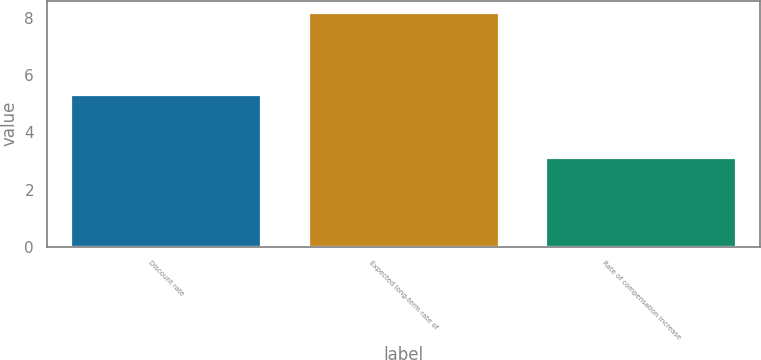Convert chart. <chart><loc_0><loc_0><loc_500><loc_500><bar_chart><fcel>Discount rate<fcel>Expected long-term rate of<fcel>Rate of compensation increase<nl><fcel>5.3<fcel>8.2<fcel>3.1<nl></chart> 